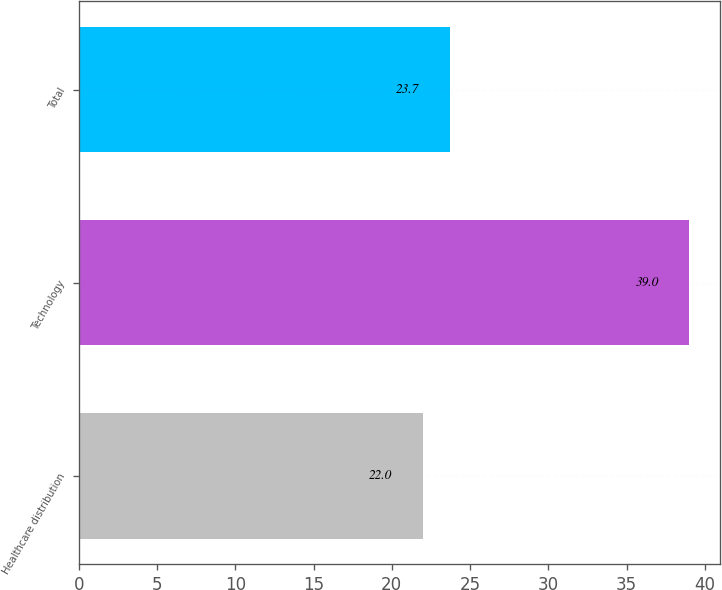Convert chart to OTSL. <chart><loc_0><loc_0><loc_500><loc_500><bar_chart><fcel>Healthcare distribution<fcel>Technology<fcel>Total<nl><fcel>22<fcel>39<fcel>23.7<nl></chart> 